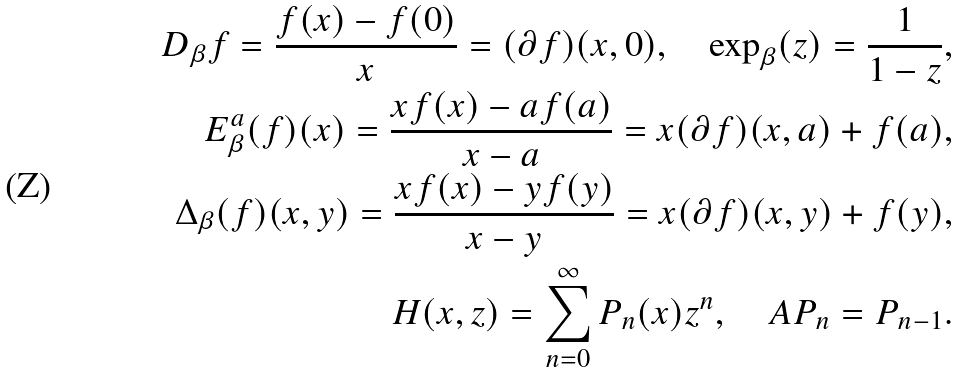<formula> <loc_0><loc_0><loc_500><loc_500>D _ { \beta } f = \frac { f ( x ) - f ( 0 ) } { x } = ( \partial f ) ( x , 0 ) , \quad \exp _ { \beta } ( z ) = \frac { 1 } { 1 - z } , \\ E ^ { a } _ { \beta } ( f ) ( x ) = \frac { x f ( x ) - a f ( a ) } { x - a } = x ( \partial f ) ( x , a ) + f ( a ) , \\ \Delta _ { \beta } ( f ) ( x , y ) = \frac { x f ( x ) - y f ( y ) } { x - y } = x ( \partial f ) ( x , y ) + f ( y ) , \\ H ( x , z ) = \sum _ { n = 0 } ^ { \infty } P _ { n } ( x ) z ^ { n } , \quad A P _ { n } = P _ { n - 1 } .</formula> 